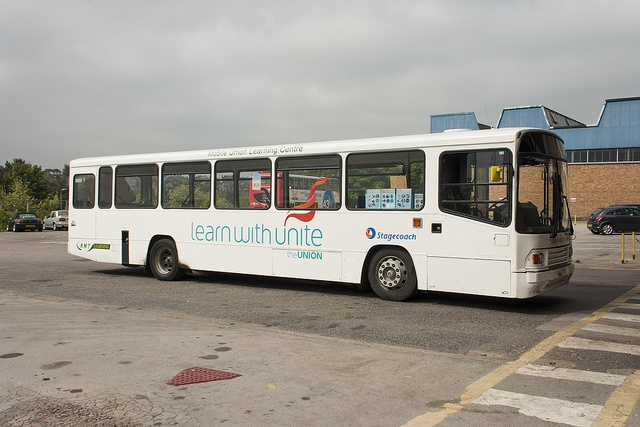Describe the objects in this image and their specific colors. I can see bus in lightgray, black, gray, and darkgray tones, car in lightgray, black, gray, purple, and maroon tones, car in lightgray, black, gray, olive, and maroon tones, and car in lightgray, gray, darkgray, and black tones in this image. 